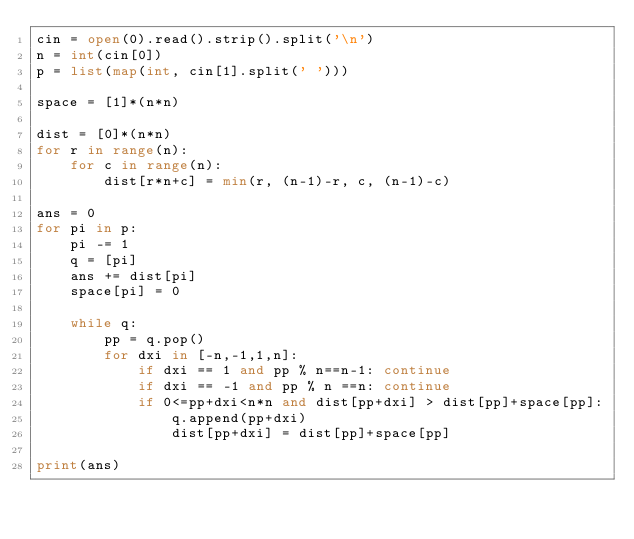Convert code to text. <code><loc_0><loc_0><loc_500><loc_500><_Python_>cin = open(0).read().strip().split('\n')
n = int(cin[0])
p = list(map(int, cin[1].split(' ')))

space = [1]*(n*n)

dist = [0]*(n*n)
for r in range(n):
    for c in range(n):
        dist[r*n+c] = min(r, (n-1)-r, c, (n-1)-c)

ans = 0
for pi in p:
    pi -= 1
    q = [pi]
    ans += dist[pi]
    space[pi] = 0

    while q:
        pp = q.pop()
        for dxi in [-n,-1,1,n]:
            if dxi == 1 and pp % n==n-1: continue
            if dxi == -1 and pp % n ==n: continue
            if 0<=pp+dxi<n*n and dist[pp+dxi] > dist[pp]+space[pp]:
                q.append(pp+dxi)
                dist[pp+dxi] = dist[pp]+space[pp]

print(ans)</code> 